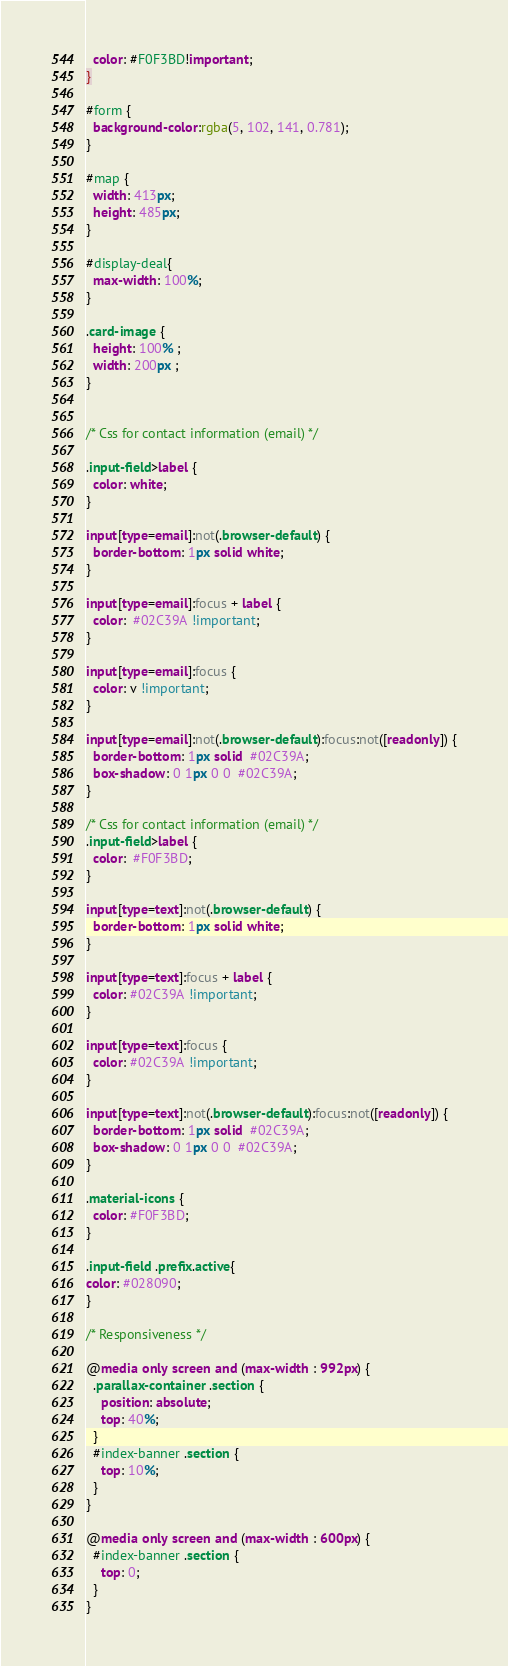<code> <loc_0><loc_0><loc_500><loc_500><_CSS_>  color: #F0F3BD!important;
}

#form {
  background-color:rgba(5, 102, 141, 0.781);
}

#map {
  width: 413px; 
  height: 485px;
}

#display-deal{
  max-width: 100%;
}

.card-image {
  height: 100% ;
  width: 200px ;
}


/* Css for contact information (email) */

.input-field>label {
  color: white;
}

input[type=email]:not(.browser-default) {
  border-bottom: 1px solid white;
}

input[type=email]:focus + label {
  color:  #02C39A !important;
}

input[type=email]:focus {
  color: v !important;
}

input[type=email]:not(.browser-default):focus:not([readonly]) {
  border-bottom: 1px solid  #02C39A;
  box-shadow: 0 1px 0 0  #02C39A;
}

/* Css for contact information (email) */
.input-field>label {
  color:  #F0F3BD;
}

input[type=text]:not(.browser-default) {
  border-bottom: 1px solid white;
}

input[type=text]:focus + label {
  color: #02C39A !important;
}

input[type=text]:focus {
  color: #02C39A !important;
}

input[type=text]:not(.browser-default):focus:not([readonly]) {
  border-bottom: 1px solid  #02C39A;
  box-shadow: 0 1px 0 0  #02C39A;
}

.material-icons {
  color: #F0F3BD;
}

.input-field .prefix.active{
color: #028090;
}

/* Responsiveness */

@media only screen and (max-width : 992px) {
  .parallax-container .section {
    position: absolute;
    top: 40%;
  }
  #index-banner .section {
    top: 10%;
  }
}

@media only screen and (max-width : 600px) {
  #index-banner .section {
    top: 0;
  }
}</code> 